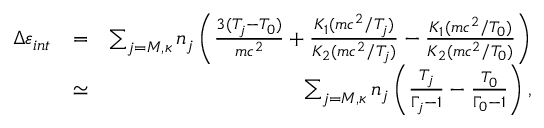Convert formula to latex. <formula><loc_0><loc_0><loc_500><loc_500>\begin{array} { r l r } { \Delta \varepsilon _ { i n t } } & { = } & { \sum _ { j = M , \kappa } n _ { j } \left ( \frac { 3 ( T _ { j } - T _ { 0 } ) } { m c ^ { 2 } } + \frac { K _ { 1 } ( m c ^ { 2 } / T _ { j } ) } { K _ { 2 } ( m c ^ { 2 } / T _ { j } ) } - \frac { K _ { 1 } ( m c ^ { 2 } / T _ { 0 } ) } { K _ { 2 } ( m c ^ { 2 } / T _ { 0 } ) } \right ) } \\ & { \simeq } & { \sum _ { j = M , \kappa } n _ { j } \left ( \frac { T _ { j } } { \Gamma _ { j } - 1 } - \frac { T _ { 0 } } { \Gamma _ { 0 } - 1 } \right ) , } \end{array}</formula> 